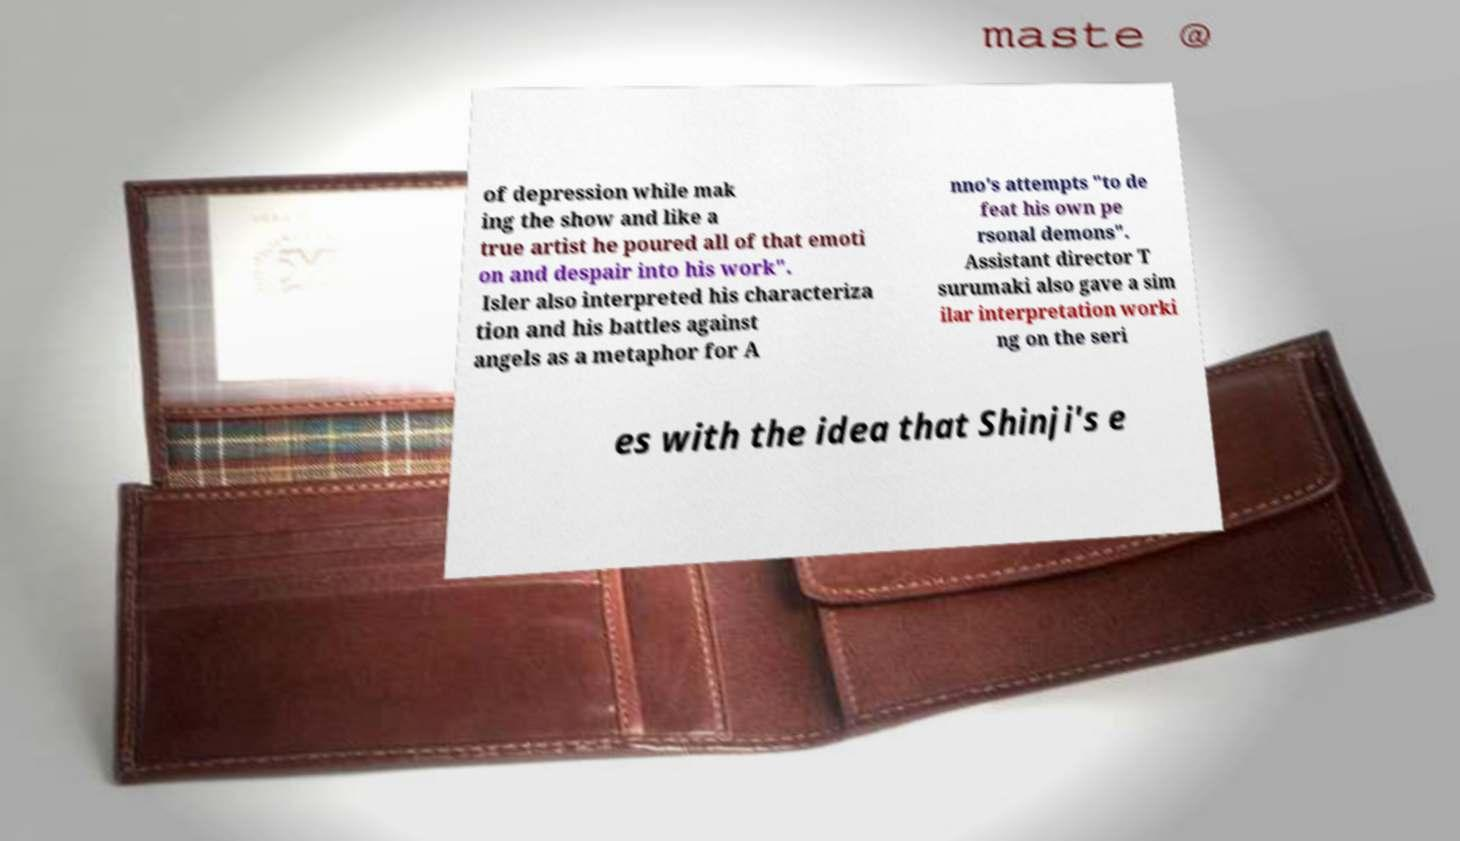Can you read and provide the text displayed in the image?This photo seems to have some interesting text. Can you extract and type it out for me? of depression while mak ing the show and like a true artist he poured all of that emoti on and despair into his work". Isler also interpreted his characteriza tion and his battles against angels as a metaphor for A nno's attempts "to de feat his own pe rsonal demons". Assistant director T surumaki also gave a sim ilar interpretation worki ng on the seri es with the idea that Shinji's e 